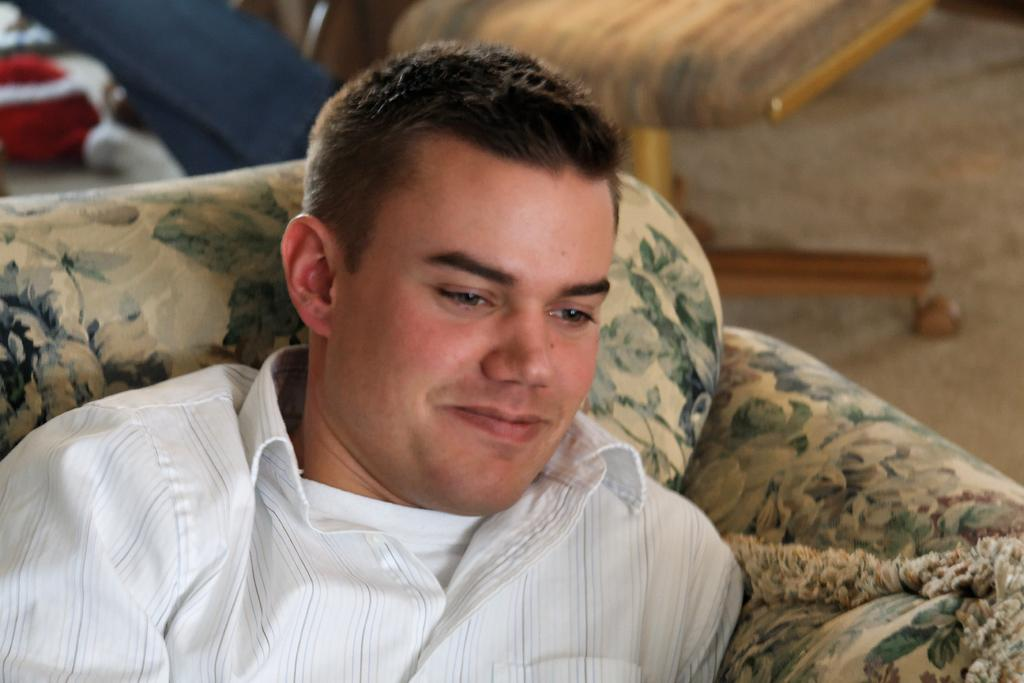Who is present in the image? There is a man in the image. What is the man doing in the image? The man is sitting on a sofa. What is the man wearing in the image? The man is wearing a t-shirt and a shirt. Can you describe any other furniture in the image? There appears to be a chair in the image. What type of meal is the man eating in the image? There is no meal present in the image; the man is sitting on a sofa and wearing a t-shirt and a shirt. Can you see any goats in the image? There are no goats present in the image. 